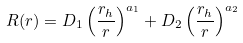<formula> <loc_0><loc_0><loc_500><loc_500>R ( r ) = D _ { 1 } \left ( \frac { r _ { h } } { r } \right ) ^ { a _ { 1 } } + D _ { 2 } \left ( \frac { r _ { h } } { r } \right ) ^ { a _ { 2 } }</formula> 